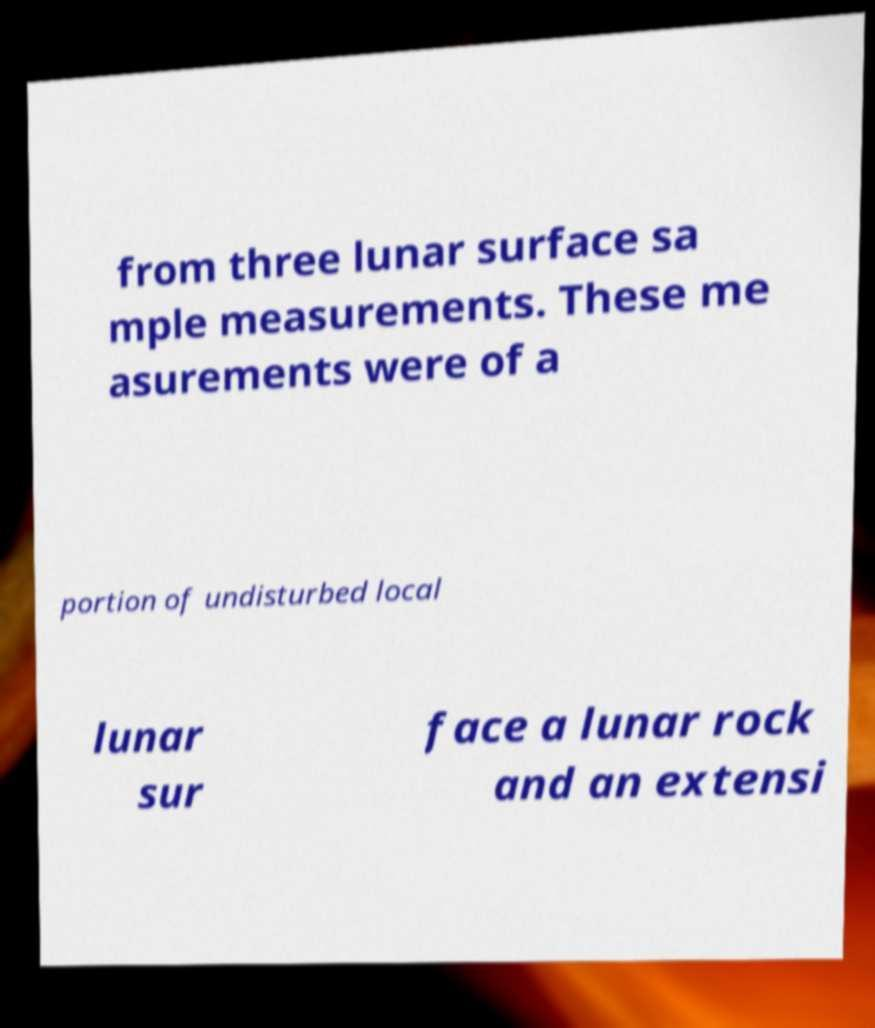Please read and relay the text visible in this image. What does it say? from three lunar surface sa mple measurements. These me asurements were of a portion of undisturbed local lunar sur face a lunar rock and an extensi 